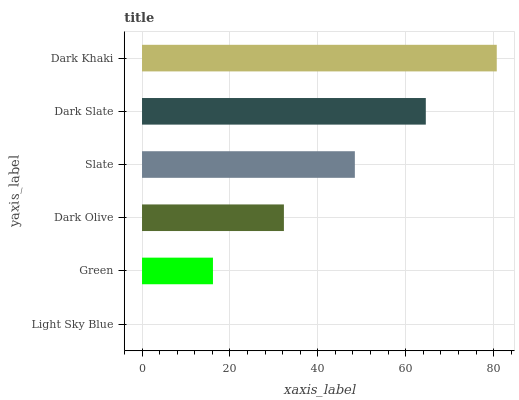Is Light Sky Blue the minimum?
Answer yes or no. Yes. Is Dark Khaki the maximum?
Answer yes or no. Yes. Is Green the minimum?
Answer yes or no. No. Is Green the maximum?
Answer yes or no. No. Is Green greater than Light Sky Blue?
Answer yes or no. Yes. Is Light Sky Blue less than Green?
Answer yes or no. Yes. Is Light Sky Blue greater than Green?
Answer yes or no. No. Is Green less than Light Sky Blue?
Answer yes or no. No. Is Slate the high median?
Answer yes or no. Yes. Is Dark Olive the low median?
Answer yes or no. Yes. Is Dark Khaki the high median?
Answer yes or no. No. Is Slate the low median?
Answer yes or no. No. 